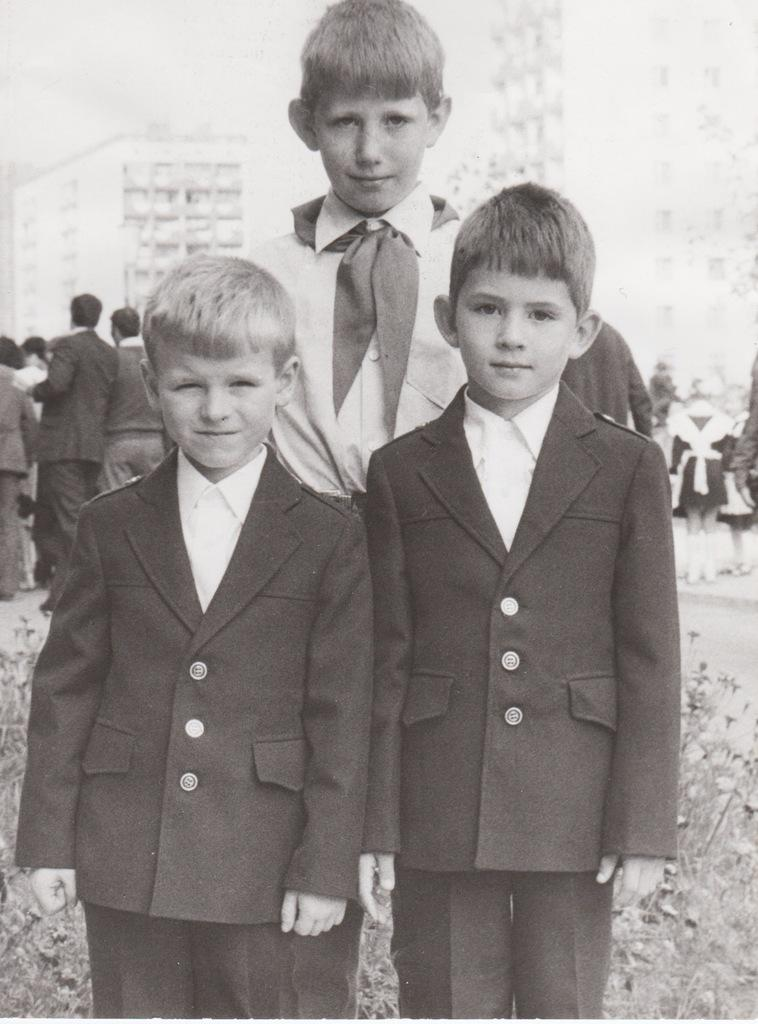How many boys are in the image? There are three boys in the image. What are the boys doing in the image? The boys are standing on the ground. What can be seen in the background of the image? There are buildings and people in the background of the image. What type of fruit is being sold by the boys in the image? There is no fruit present in the image, and the boys are not selling anything. 